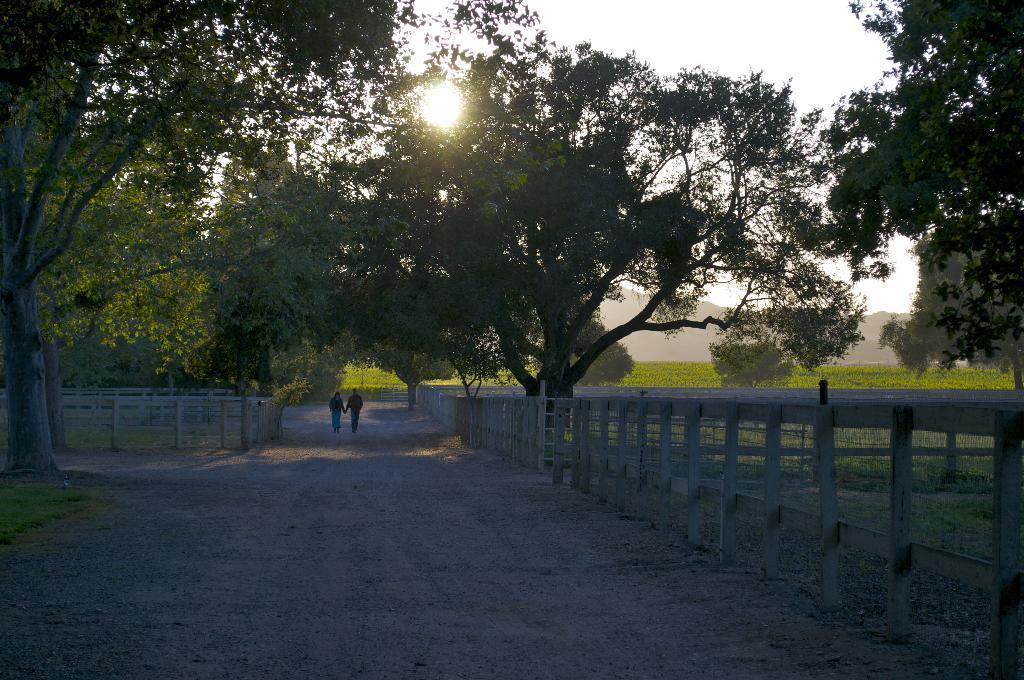Can you describe this image briefly? In this image I can see the road, two persons standing on the road, the railing, few trees, some grass and in the background I can see a mountain, the sky and the sun. 